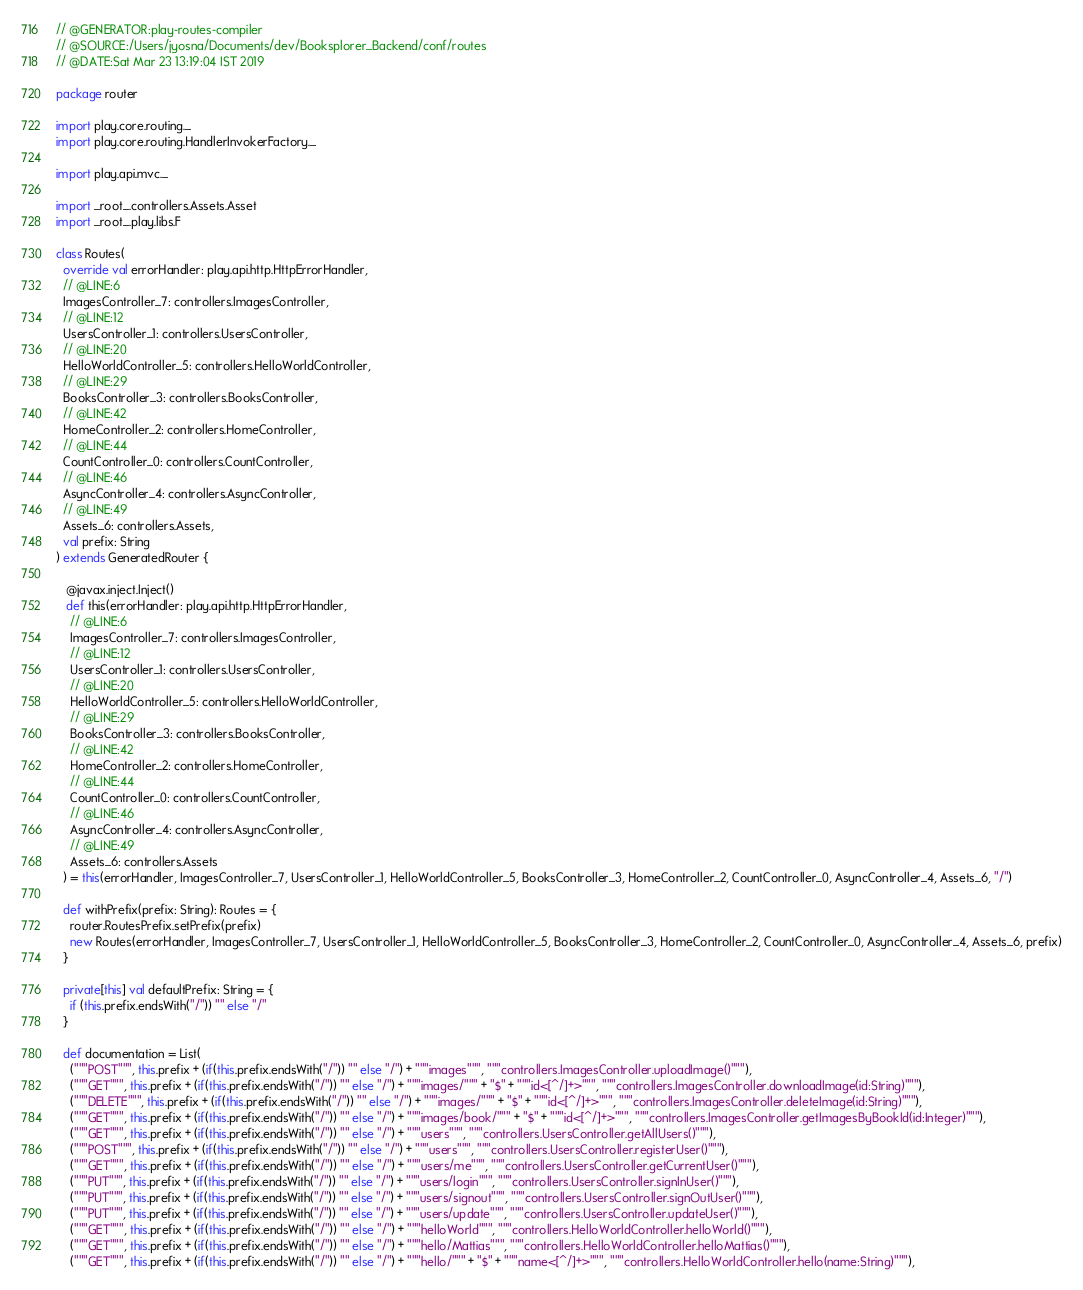<code> <loc_0><loc_0><loc_500><loc_500><_Scala_>// @GENERATOR:play-routes-compiler
// @SOURCE:/Users/jyosna/Documents/dev/Booksplorer_Backend/conf/routes
// @DATE:Sat Mar 23 13:19:04 IST 2019

package router

import play.core.routing._
import play.core.routing.HandlerInvokerFactory._

import play.api.mvc._

import _root_.controllers.Assets.Asset
import _root_.play.libs.F

class Routes(
  override val errorHandler: play.api.http.HttpErrorHandler, 
  // @LINE:6
  ImagesController_7: controllers.ImagesController,
  // @LINE:12
  UsersController_1: controllers.UsersController,
  // @LINE:20
  HelloWorldController_5: controllers.HelloWorldController,
  // @LINE:29
  BooksController_3: controllers.BooksController,
  // @LINE:42
  HomeController_2: controllers.HomeController,
  // @LINE:44
  CountController_0: controllers.CountController,
  // @LINE:46
  AsyncController_4: controllers.AsyncController,
  // @LINE:49
  Assets_6: controllers.Assets,
  val prefix: String
) extends GeneratedRouter {

   @javax.inject.Inject()
   def this(errorHandler: play.api.http.HttpErrorHandler,
    // @LINE:6
    ImagesController_7: controllers.ImagesController,
    // @LINE:12
    UsersController_1: controllers.UsersController,
    // @LINE:20
    HelloWorldController_5: controllers.HelloWorldController,
    // @LINE:29
    BooksController_3: controllers.BooksController,
    // @LINE:42
    HomeController_2: controllers.HomeController,
    // @LINE:44
    CountController_0: controllers.CountController,
    // @LINE:46
    AsyncController_4: controllers.AsyncController,
    // @LINE:49
    Assets_6: controllers.Assets
  ) = this(errorHandler, ImagesController_7, UsersController_1, HelloWorldController_5, BooksController_3, HomeController_2, CountController_0, AsyncController_4, Assets_6, "/")

  def withPrefix(prefix: String): Routes = {
    router.RoutesPrefix.setPrefix(prefix)
    new Routes(errorHandler, ImagesController_7, UsersController_1, HelloWorldController_5, BooksController_3, HomeController_2, CountController_0, AsyncController_4, Assets_6, prefix)
  }

  private[this] val defaultPrefix: String = {
    if (this.prefix.endsWith("/")) "" else "/"
  }

  def documentation = List(
    ("""POST""", this.prefix + (if(this.prefix.endsWith("/")) "" else "/") + """images""", """controllers.ImagesController.uploadImage()"""),
    ("""GET""", this.prefix + (if(this.prefix.endsWith("/")) "" else "/") + """images/""" + "$" + """id<[^/]+>""", """controllers.ImagesController.downloadImage(id:String)"""),
    ("""DELETE""", this.prefix + (if(this.prefix.endsWith("/")) "" else "/") + """images/""" + "$" + """id<[^/]+>""", """controllers.ImagesController.deleteImage(id:String)"""),
    ("""GET""", this.prefix + (if(this.prefix.endsWith("/")) "" else "/") + """images/book/""" + "$" + """id<[^/]+>""", """controllers.ImagesController.getImagesByBookId(id:Integer)"""),
    ("""GET""", this.prefix + (if(this.prefix.endsWith("/")) "" else "/") + """users""", """controllers.UsersController.getAllUsers()"""),
    ("""POST""", this.prefix + (if(this.prefix.endsWith("/")) "" else "/") + """users""", """controllers.UsersController.registerUser()"""),
    ("""GET""", this.prefix + (if(this.prefix.endsWith("/")) "" else "/") + """users/me""", """controllers.UsersController.getCurrentUser()"""),
    ("""PUT""", this.prefix + (if(this.prefix.endsWith("/")) "" else "/") + """users/login""", """controllers.UsersController.signInUser()"""),
    ("""PUT""", this.prefix + (if(this.prefix.endsWith("/")) "" else "/") + """users/signout""", """controllers.UsersController.signOutUser()"""),
    ("""PUT""", this.prefix + (if(this.prefix.endsWith("/")) "" else "/") + """users/update""", """controllers.UsersController.updateUser()"""),
    ("""GET""", this.prefix + (if(this.prefix.endsWith("/")) "" else "/") + """helloWorld""", """controllers.HelloWorldController.helloWorld()"""),
    ("""GET""", this.prefix + (if(this.prefix.endsWith("/")) "" else "/") + """hello/Mattias""", """controllers.HelloWorldController.helloMattias()"""),
    ("""GET""", this.prefix + (if(this.prefix.endsWith("/")) "" else "/") + """hello/""" + "$" + """name<[^/]+>""", """controllers.HelloWorldController.hello(name:String)"""),</code> 